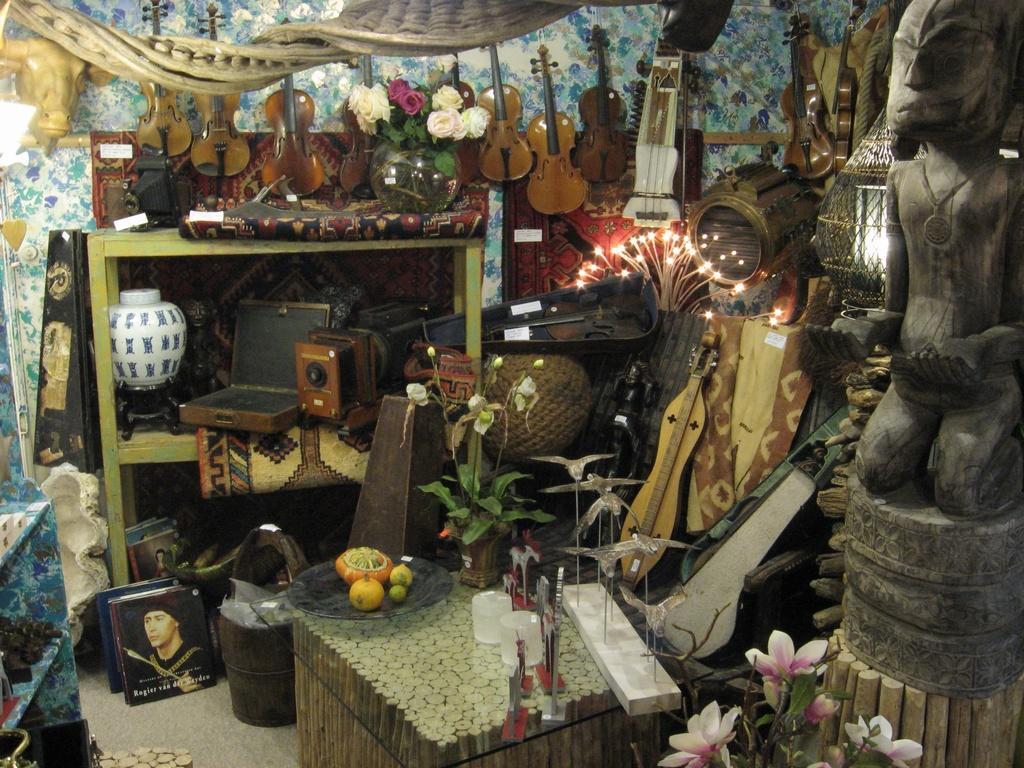Please provide a concise description of this image. In this image, we can see some guitars on the wall and we can see some musical instruments, on the right side we can see a statue. 